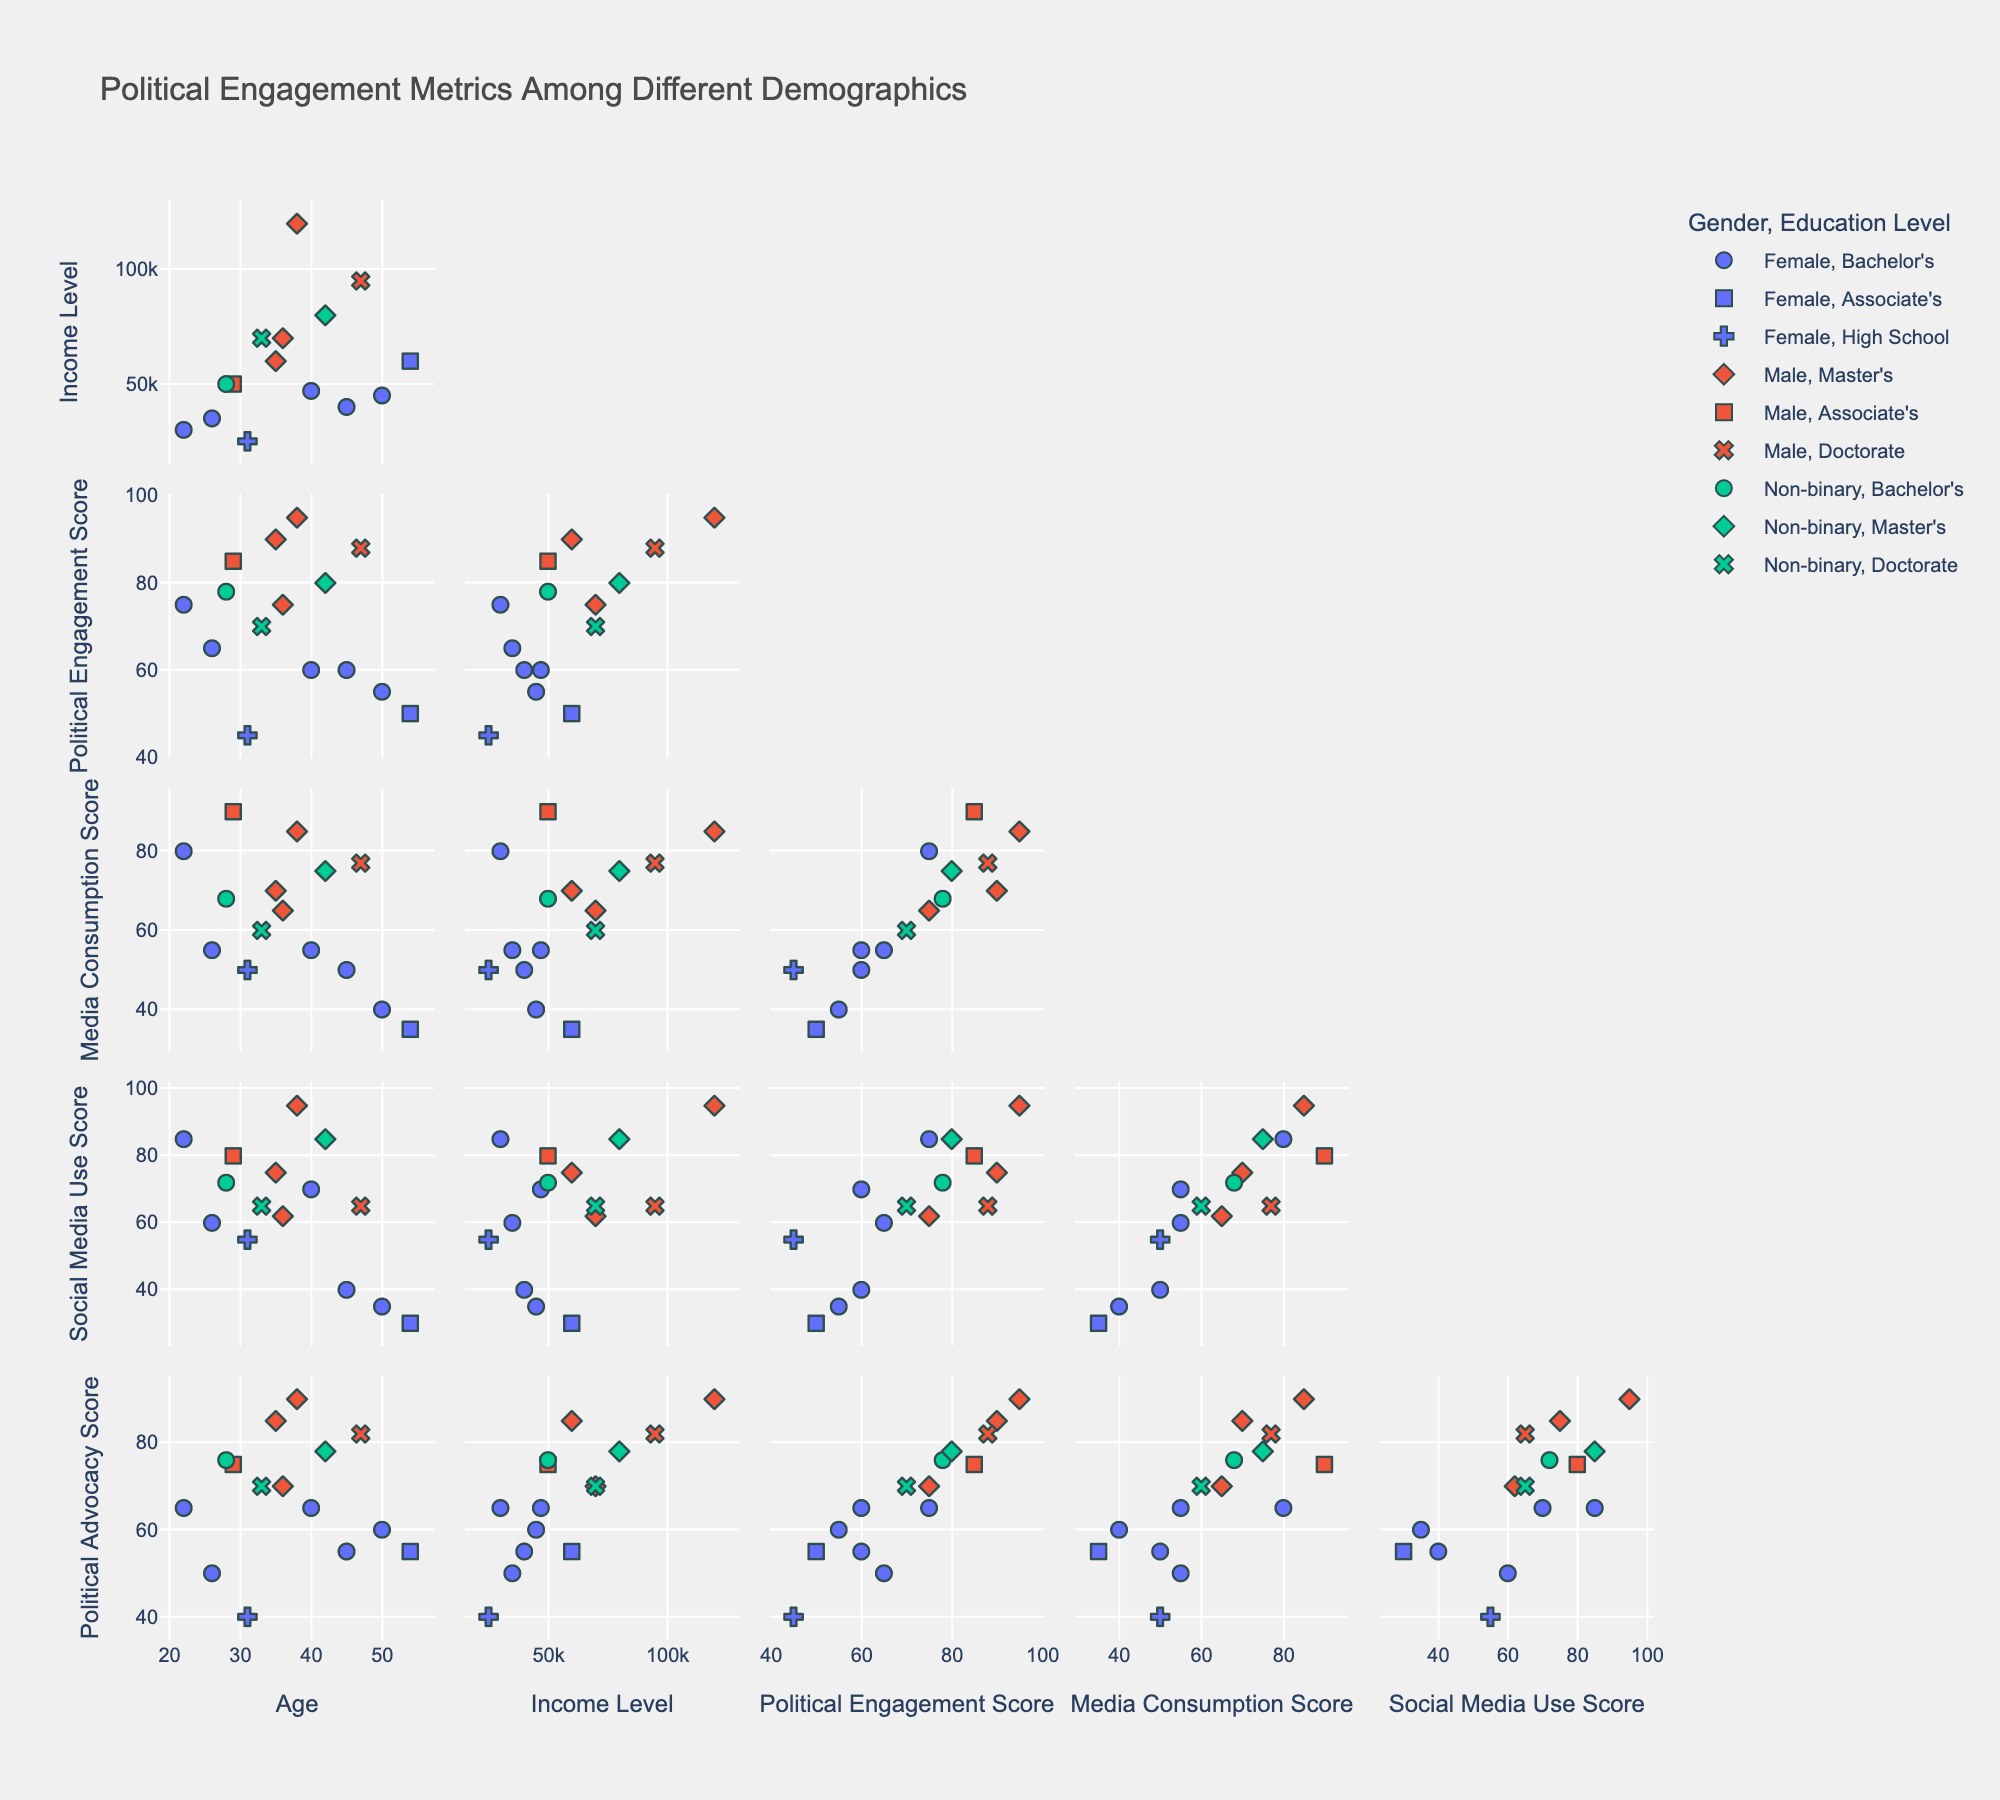What is the title of the scatter plot matrix? Look at the top of the figure where the title is usually displayed. The text "Political Engagement Metrics Among Different Demographics" is shown.
Answer: Political Engagement Metrics Among Different Demographics How many variables are represented in the scatter plot matrix? Count the number of unique variables listed on either the x-axis or y-axis. There should be six: Age, Income Level, Political Engagement Score, Media Consumption Score, Social Media Use Score, Political Advocacy Score.
Answer: Six Which gender appears to have a higher Political Engagement Score on average, Male or Female? By viewing the distribution of Political Engagement Scores for Male and Female, note that Male data points generally seem higher.
Answer: Male For individuals with a Master's degree, what is the general trend between Media Consumption Score and Social Media Use Score? Look at the scatter plot where individuals with a Master's degree are symbolized, and observe how Media Consumption Score relates to Social Media Use Score. The general trend shows a positive correlation.
Answer: Positive correlation Do people with a Doctorate degree generally have higher or lower Income Levels compared to those with a Bachelor's degree? Compare the Income Levels of data points with a Doctorate symbol to those with a Bachelor's symbol. Those with a Doctorate generally appear to have higher Income Levels.
Answer: Higher What is the relationship between Age and Political Engagement Score? Look at the scatter plot matrix cell where Age is plotted against Political Engagement Score. Observe if there is a visible trend such as a positive or negative correlation or no correlation at all. The relationship shows a very slight positive trend.
Answer: Slight positive trend Who has the highest Political Advocacy Score, and what is their age and gender? Locate the highest point on the Political Advocacy Score axis and identify the corresponding age and gender by checking hover details or associated markers. This highest score point (90) corresponds to a Male aged 38.
Answer: Male, 38 Which education level is associated with the highest Media Consumption Score on average? Identify the points with different education levels and compare their Media Consumption Scores. Note that the Master's degree group generally shows the higher average media consumption scores.
Answer: Master's degree Is there a gender that dominates in the high-income bracket (above 80000)? Look at the points in the scatter plot matrix representing Income Level with values above 80000 and observe the gender distribution. Males dominate the higher income bracket.
Answer: Male Do younger adults (under 30) show higher Social Media Use Scores compared to older adults (above 30)? Compare the scatter plot points of individuals aged under 30 against those above 30, focusing on their Social Media Use Scores. Younger adults consistently show higher scores.
Answer: Under 30 